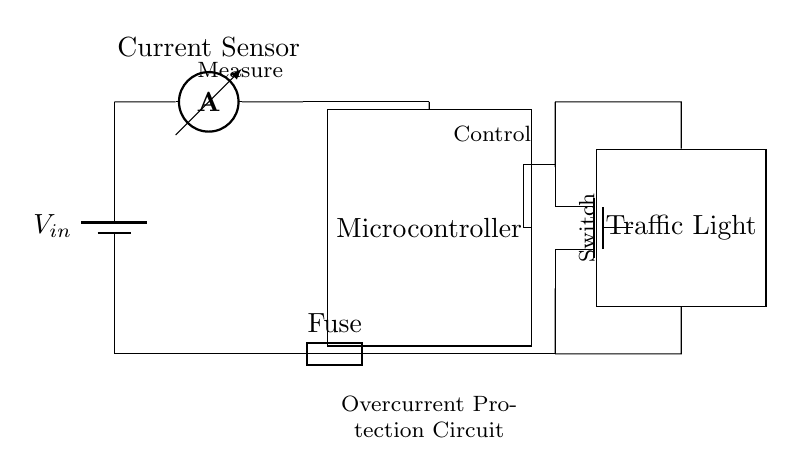What type of battery is used in this circuit? The circuit diagram indicates a generic battery symbol, which typically represents a direct current power supply. Therefore, the type of battery is a DC battery.
Answer: DC battery What does the ammeter measure in the circuit? The ammeter is labeled as the "Current Sensor," which means it measures the flow of electric current in the circuit.
Answer: Current Which component acts as a switch in this circuit? The MOSFET, specifically marked as 'mosfet,' is controlling the flow of current and acts as a switch.
Answer: MOSFET What happens to the traffic light if the current exceeds a certain limit? The fuse, shown in the circuit, functions as an overcurrent protection device that will blow and interrupt the current flow, turning off the traffic light.
Answer: Traffic light turns off How is the microcontroller connected in this circuit? The microcontroller is directly connected to the current sensor and the MOSFET, receiving measurements to control the flow of current to the traffic light. This shows that it operates within the circuit to manage its functions.
Answer: Direct connection Where does the current flow after the fuse? After the fuse, the current flows to the MOSFET, which then directs the current to the traffic light load, completing the circuit.
Answer: To the MOSFET What role does the fuse play in this circuit? The fuse serves as a protective component that prevents excess current from damaging other circuit components by breaking the circuit when an overcurrent occurs.
Answer: Overcurrent protection 